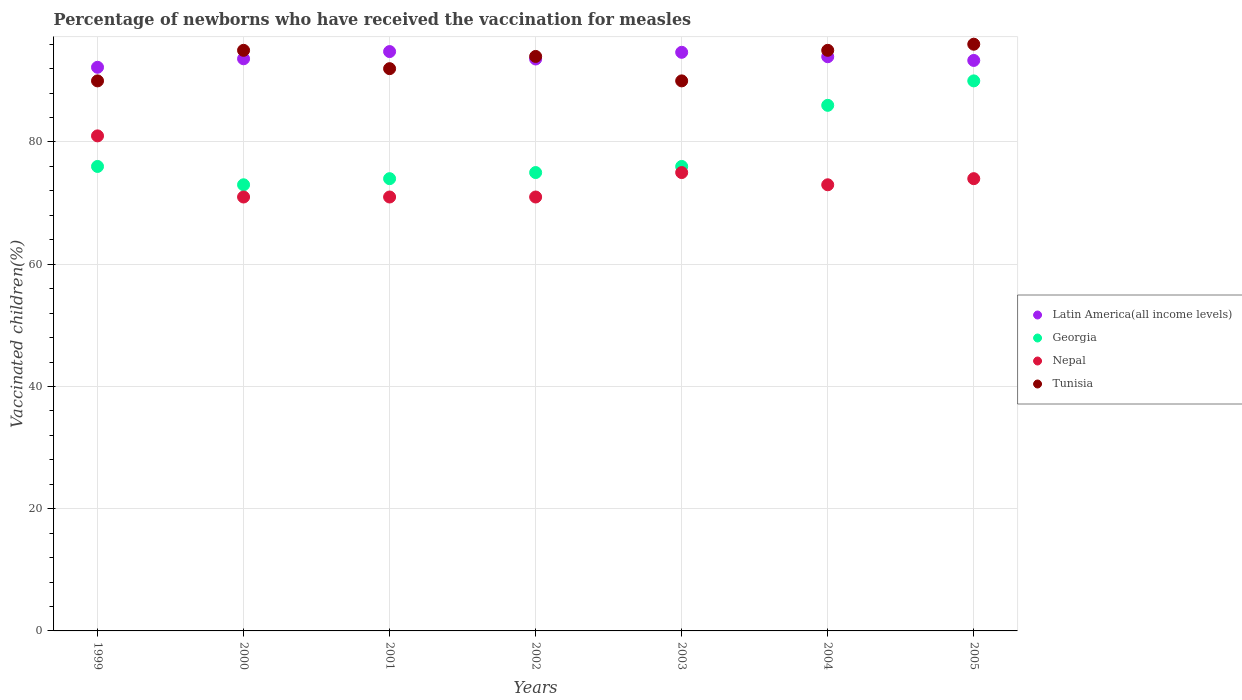Is the number of dotlines equal to the number of legend labels?
Offer a terse response. Yes. Across all years, what is the maximum percentage of vaccinated children in Nepal?
Offer a terse response. 81. In which year was the percentage of vaccinated children in Tunisia minimum?
Provide a short and direct response. 1999. What is the total percentage of vaccinated children in Nepal in the graph?
Provide a short and direct response. 516. What is the difference between the percentage of vaccinated children in Latin America(all income levels) in 1999 and that in 2002?
Keep it short and to the point. -1.36. What is the difference between the percentage of vaccinated children in Tunisia in 1999 and the percentage of vaccinated children in Georgia in 2005?
Provide a succinct answer. 0. What is the average percentage of vaccinated children in Latin America(all income levels) per year?
Your response must be concise. 93.74. In the year 2001, what is the difference between the percentage of vaccinated children in Latin America(all income levels) and percentage of vaccinated children in Nepal?
Provide a short and direct response. 23.8. In how many years, is the percentage of vaccinated children in Georgia greater than 60 %?
Your answer should be compact. 7. What is the ratio of the percentage of vaccinated children in Latin America(all income levels) in 2002 to that in 2003?
Your answer should be compact. 0.99. Is the percentage of vaccinated children in Nepal in 2000 less than that in 2002?
Ensure brevity in your answer.  No. What is the difference between the highest and the second highest percentage of vaccinated children in Nepal?
Keep it short and to the point. 6. What is the difference between the highest and the lowest percentage of vaccinated children in Latin America(all income levels)?
Offer a terse response. 2.57. Is the sum of the percentage of vaccinated children in Georgia in 2000 and 2001 greater than the maximum percentage of vaccinated children in Latin America(all income levels) across all years?
Offer a very short reply. Yes. Is it the case that in every year, the sum of the percentage of vaccinated children in Nepal and percentage of vaccinated children in Georgia  is greater than the sum of percentage of vaccinated children in Latin America(all income levels) and percentage of vaccinated children in Tunisia?
Make the answer very short. No. Is it the case that in every year, the sum of the percentage of vaccinated children in Latin America(all income levels) and percentage of vaccinated children in Georgia  is greater than the percentage of vaccinated children in Tunisia?
Keep it short and to the point. Yes. Is the percentage of vaccinated children in Georgia strictly greater than the percentage of vaccinated children in Tunisia over the years?
Ensure brevity in your answer.  No. What is the difference between two consecutive major ticks on the Y-axis?
Ensure brevity in your answer.  20. Are the values on the major ticks of Y-axis written in scientific E-notation?
Keep it short and to the point. No. How many legend labels are there?
Ensure brevity in your answer.  4. How are the legend labels stacked?
Your response must be concise. Vertical. What is the title of the graph?
Your response must be concise. Percentage of newborns who have received the vaccination for measles. What is the label or title of the Y-axis?
Provide a short and direct response. Vaccinated children(%). What is the Vaccinated children(%) of Latin America(all income levels) in 1999?
Your answer should be very brief. 92.23. What is the Vaccinated children(%) in Georgia in 1999?
Your response must be concise. 76. What is the Vaccinated children(%) in Tunisia in 1999?
Offer a very short reply. 90. What is the Vaccinated children(%) of Latin America(all income levels) in 2000?
Give a very brief answer. 93.62. What is the Vaccinated children(%) in Latin America(all income levels) in 2001?
Provide a short and direct response. 94.8. What is the Vaccinated children(%) in Georgia in 2001?
Offer a very short reply. 74. What is the Vaccinated children(%) in Tunisia in 2001?
Make the answer very short. 92. What is the Vaccinated children(%) in Latin America(all income levels) in 2002?
Give a very brief answer. 93.58. What is the Vaccinated children(%) in Georgia in 2002?
Keep it short and to the point. 75. What is the Vaccinated children(%) in Nepal in 2002?
Your answer should be compact. 71. What is the Vaccinated children(%) of Tunisia in 2002?
Ensure brevity in your answer.  94. What is the Vaccinated children(%) in Latin America(all income levels) in 2003?
Make the answer very short. 94.68. What is the Vaccinated children(%) in Nepal in 2003?
Your answer should be compact. 75. What is the Vaccinated children(%) of Tunisia in 2003?
Provide a short and direct response. 90. What is the Vaccinated children(%) in Latin America(all income levels) in 2004?
Make the answer very short. 93.95. What is the Vaccinated children(%) of Georgia in 2004?
Offer a terse response. 86. What is the Vaccinated children(%) of Nepal in 2004?
Your answer should be very brief. 73. What is the Vaccinated children(%) of Latin America(all income levels) in 2005?
Your answer should be very brief. 93.35. What is the Vaccinated children(%) in Tunisia in 2005?
Make the answer very short. 96. Across all years, what is the maximum Vaccinated children(%) in Latin America(all income levels)?
Your answer should be very brief. 94.8. Across all years, what is the maximum Vaccinated children(%) of Georgia?
Offer a terse response. 90. Across all years, what is the maximum Vaccinated children(%) of Tunisia?
Provide a succinct answer. 96. Across all years, what is the minimum Vaccinated children(%) of Latin America(all income levels)?
Ensure brevity in your answer.  92.23. Across all years, what is the minimum Vaccinated children(%) in Georgia?
Your response must be concise. 73. Across all years, what is the minimum Vaccinated children(%) in Nepal?
Ensure brevity in your answer.  71. What is the total Vaccinated children(%) of Latin America(all income levels) in the graph?
Provide a succinct answer. 656.2. What is the total Vaccinated children(%) in Georgia in the graph?
Ensure brevity in your answer.  550. What is the total Vaccinated children(%) of Nepal in the graph?
Your answer should be compact. 516. What is the total Vaccinated children(%) in Tunisia in the graph?
Offer a very short reply. 652. What is the difference between the Vaccinated children(%) of Latin America(all income levels) in 1999 and that in 2000?
Ensure brevity in your answer.  -1.39. What is the difference between the Vaccinated children(%) in Georgia in 1999 and that in 2000?
Provide a succinct answer. 3. What is the difference between the Vaccinated children(%) of Nepal in 1999 and that in 2000?
Ensure brevity in your answer.  10. What is the difference between the Vaccinated children(%) in Tunisia in 1999 and that in 2000?
Give a very brief answer. -5. What is the difference between the Vaccinated children(%) of Latin America(all income levels) in 1999 and that in 2001?
Your answer should be compact. -2.57. What is the difference between the Vaccinated children(%) in Tunisia in 1999 and that in 2001?
Provide a succinct answer. -2. What is the difference between the Vaccinated children(%) of Latin America(all income levels) in 1999 and that in 2002?
Give a very brief answer. -1.36. What is the difference between the Vaccinated children(%) in Georgia in 1999 and that in 2002?
Provide a succinct answer. 1. What is the difference between the Vaccinated children(%) of Latin America(all income levels) in 1999 and that in 2003?
Ensure brevity in your answer.  -2.45. What is the difference between the Vaccinated children(%) of Georgia in 1999 and that in 2003?
Make the answer very short. 0. What is the difference between the Vaccinated children(%) in Tunisia in 1999 and that in 2003?
Make the answer very short. 0. What is the difference between the Vaccinated children(%) of Latin America(all income levels) in 1999 and that in 2004?
Provide a short and direct response. -1.73. What is the difference between the Vaccinated children(%) of Latin America(all income levels) in 1999 and that in 2005?
Provide a short and direct response. -1.12. What is the difference between the Vaccinated children(%) of Georgia in 1999 and that in 2005?
Ensure brevity in your answer.  -14. What is the difference between the Vaccinated children(%) of Tunisia in 1999 and that in 2005?
Provide a short and direct response. -6. What is the difference between the Vaccinated children(%) in Latin America(all income levels) in 2000 and that in 2001?
Offer a terse response. -1.18. What is the difference between the Vaccinated children(%) of Georgia in 2000 and that in 2001?
Provide a succinct answer. -1. What is the difference between the Vaccinated children(%) of Nepal in 2000 and that in 2001?
Your answer should be very brief. 0. What is the difference between the Vaccinated children(%) in Tunisia in 2000 and that in 2001?
Ensure brevity in your answer.  3. What is the difference between the Vaccinated children(%) of Latin America(all income levels) in 2000 and that in 2002?
Make the answer very short. 0.03. What is the difference between the Vaccinated children(%) in Georgia in 2000 and that in 2002?
Give a very brief answer. -2. What is the difference between the Vaccinated children(%) in Latin America(all income levels) in 2000 and that in 2003?
Your answer should be very brief. -1.06. What is the difference between the Vaccinated children(%) of Nepal in 2000 and that in 2003?
Your response must be concise. -4. What is the difference between the Vaccinated children(%) of Latin America(all income levels) in 2000 and that in 2004?
Make the answer very short. -0.34. What is the difference between the Vaccinated children(%) in Latin America(all income levels) in 2000 and that in 2005?
Provide a short and direct response. 0.27. What is the difference between the Vaccinated children(%) in Tunisia in 2000 and that in 2005?
Make the answer very short. -1. What is the difference between the Vaccinated children(%) in Latin America(all income levels) in 2001 and that in 2002?
Keep it short and to the point. 1.21. What is the difference between the Vaccinated children(%) in Georgia in 2001 and that in 2002?
Offer a terse response. -1. What is the difference between the Vaccinated children(%) in Nepal in 2001 and that in 2002?
Offer a terse response. 0. What is the difference between the Vaccinated children(%) in Tunisia in 2001 and that in 2002?
Provide a succinct answer. -2. What is the difference between the Vaccinated children(%) of Latin America(all income levels) in 2001 and that in 2003?
Your answer should be very brief. 0.12. What is the difference between the Vaccinated children(%) of Tunisia in 2001 and that in 2003?
Offer a very short reply. 2. What is the difference between the Vaccinated children(%) of Latin America(all income levels) in 2001 and that in 2004?
Your answer should be very brief. 0.84. What is the difference between the Vaccinated children(%) of Georgia in 2001 and that in 2004?
Give a very brief answer. -12. What is the difference between the Vaccinated children(%) in Nepal in 2001 and that in 2004?
Keep it short and to the point. -2. What is the difference between the Vaccinated children(%) in Tunisia in 2001 and that in 2004?
Provide a short and direct response. -3. What is the difference between the Vaccinated children(%) of Latin America(all income levels) in 2001 and that in 2005?
Provide a short and direct response. 1.45. What is the difference between the Vaccinated children(%) in Georgia in 2001 and that in 2005?
Your answer should be very brief. -16. What is the difference between the Vaccinated children(%) in Nepal in 2001 and that in 2005?
Ensure brevity in your answer.  -3. What is the difference between the Vaccinated children(%) of Tunisia in 2001 and that in 2005?
Give a very brief answer. -4. What is the difference between the Vaccinated children(%) of Latin America(all income levels) in 2002 and that in 2003?
Provide a succinct answer. -1.09. What is the difference between the Vaccinated children(%) in Latin America(all income levels) in 2002 and that in 2004?
Your answer should be very brief. -0.37. What is the difference between the Vaccinated children(%) of Georgia in 2002 and that in 2004?
Make the answer very short. -11. What is the difference between the Vaccinated children(%) of Nepal in 2002 and that in 2004?
Ensure brevity in your answer.  -2. What is the difference between the Vaccinated children(%) in Latin America(all income levels) in 2002 and that in 2005?
Your answer should be very brief. 0.24. What is the difference between the Vaccinated children(%) of Georgia in 2002 and that in 2005?
Offer a very short reply. -15. What is the difference between the Vaccinated children(%) in Tunisia in 2002 and that in 2005?
Provide a succinct answer. -2. What is the difference between the Vaccinated children(%) in Latin America(all income levels) in 2003 and that in 2004?
Provide a succinct answer. 0.72. What is the difference between the Vaccinated children(%) in Latin America(all income levels) in 2003 and that in 2005?
Your answer should be compact. 1.33. What is the difference between the Vaccinated children(%) in Georgia in 2003 and that in 2005?
Ensure brevity in your answer.  -14. What is the difference between the Vaccinated children(%) of Nepal in 2003 and that in 2005?
Offer a very short reply. 1. What is the difference between the Vaccinated children(%) of Tunisia in 2003 and that in 2005?
Offer a terse response. -6. What is the difference between the Vaccinated children(%) of Latin America(all income levels) in 2004 and that in 2005?
Your response must be concise. 0.61. What is the difference between the Vaccinated children(%) in Nepal in 2004 and that in 2005?
Provide a succinct answer. -1. What is the difference between the Vaccinated children(%) in Latin America(all income levels) in 1999 and the Vaccinated children(%) in Georgia in 2000?
Provide a short and direct response. 19.23. What is the difference between the Vaccinated children(%) in Latin America(all income levels) in 1999 and the Vaccinated children(%) in Nepal in 2000?
Your answer should be very brief. 21.23. What is the difference between the Vaccinated children(%) in Latin America(all income levels) in 1999 and the Vaccinated children(%) in Tunisia in 2000?
Offer a very short reply. -2.77. What is the difference between the Vaccinated children(%) in Georgia in 1999 and the Vaccinated children(%) in Nepal in 2000?
Provide a short and direct response. 5. What is the difference between the Vaccinated children(%) in Georgia in 1999 and the Vaccinated children(%) in Tunisia in 2000?
Give a very brief answer. -19. What is the difference between the Vaccinated children(%) of Latin America(all income levels) in 1999 and the Vaccinated children(%) of Georgia in 2001?
Give a very brief answer. 18.23. What is the difference between the Vaccinated children(%) in Latin America(all income levels) in 1999 and the Vaccinated children(%) in Nepal in 2001?
Ensure brevity in your answer.  21.23. What is the difference between the Vaccinated children(%) of Latin America(all income levels) in 1999 and the Vaccinated children(%) of Tunisia in 2001?
Your answer should be very brief. 0.23. What is the difference between the Vaccinated children(%) of Georgia in 1999 and the Vaccinated children(%) of Tunisia in 2001?
Keep it short and to the point. -16. What is the difference between the Vaccinated children(%) of Latin America(all income levels) in 1999 and the Vaccinated children(%) of Georgia in 2002?
Your answer should be compact. 17.23. What is the difference between the Vaccinated children(%) in Latin America(all income levels) in 1999 and the Vaccinated children(%) in Nepal in 2002?
Keep it short and to the point. 21.23. What is the difference between the Vaccinated children(%) of Latin America(all income levels) in 1999 and the Vaccinated children(%) of Tunisia in 2002?
Provide a short and direct response. -1.77. What is the difference between the Vaccinated children(%) of Georgia in 1999 and the Vaccinated children(%) of Nepal in 2002?
Ensure brevity in your answer.  5. What is the difference between the Vaccinated children(%) in Georgia in 1999 and the Vaccinated children(%) in Tunisia in 2002?
Your answer should be very brief. -18. What is the difference between the Vaccinated children(%) of Latin America(all income levels) in 1999 and the Vaccinated children(%) of Georgia in 2003?
Your response must be concise. 16.23. What is the difference between the Vaccinated children(%) of Latin America(all income levels) in 1999 and the Vaccinated children(%) of Nepal in 2003?
Offer a terse response. 17.23. What is the difference between the Vaccinated children(%) of Latin America(all income levels) in 1999 and the Vaccinated children(%) of Tunisia in 2003?
Offer a very short reply. 2.23. What is the difference between the Vaccinated children(%) of Latin America(all income levels) in 1999 and the Vaccinated children(%) of Georgia in 2004?
Your answer should be very brief. 6.23. What is the difference between the Vaccinated children(%) of Latin America(all income levels) in 1999 and the Vaccinated children(%) of Nepal in 2004?
Give a very brief answer. 19.23. What is the difference between the Vaccinated children(%) of Latin America(all income levels) in 1999 and the Vaccinated children(%) of Tunisia in 2004?
Your response must be concise. -2.77. What is the difference between the Vaccinated children(%) of Georgia in 1999 and the Vaccinated children(%) of Tunisia in 2004?
Provide a succinct answer. -19. What is the difference between the Vaccinated children(%) in Nepal in 1999 and the Vaccinated children(%) in Tunisia in 2004?
Ensure brevity in your answer.  -14. What is the difference between the Vaccinated children(%) of Latin America(all income levels) in 1999 and the Vaccinated children(%) of Georgia in 2005?
Your answer should be very brief. 2.23. What is the difference between the Vaccinated children(%) of Latin America(all income levels) in 1999 and the Vaccinated children(%) of Nepal in 2005?
Keep it short and to the point. 18.23. What is the difference between the Vaccinated children(%) in Latin America(all income levels) in 1999 and the Vaccinated children(%) in Tunisia in 2005?
Your answer should be compact. -3.77. What is the difference between the Vaccinated children(%) of Latin America(all income levels) in 2000 and the Vaccinated children(%) of Georgia in 2001?
Ensure brevity in your answer.  19.62. What is the difference between the Vaccinated children(%) in Latin America(all income levels) in 2000 and the Vaccinated children(%) in Nepal in 2001?
Ensure brevity in your answer.  22.62. What is the difference between the Vaccinated children(%) of Latin America(all income levels) in 2000 and the Vaccinated children(%) of Tunisia in 2001?
Offer a terse response. 1.62. What is the difference between the Vaccinated children(%) in Georgia in 2000 and the Vaccinated children(%) in Nepal in 2001?
Give a very brief answer. 2. What is the difference between the Vaccinated children(%) of Georgia in 2000 and the Vaccinated children(%) of Tunisia in 2001?
Provide a succinct answer. -19. What is the difference between the Vaccinated children(%) of Latin America(all income levels) in 2000 and the Vaccinated children(%) of Georgia in 2002?
Offer a terse response. 18.62. What is the difference between the Vaccinated children(%) of Latin America(all income levels) in 2000 and the Vaccinated children(%) of Nepal in 2002?
Offer a very short reply. 22.62. What is the difference between the Vaccinated children(%) in Latin America(all income levels) in 2000 and the Vaccinated children(%) in Tunisia in 2002?
Offer a very short reply. -0.38. What is the difference between the Vaccinated children(%) in Georgia in 2000 and the Vaccinated children(%) in Tunisia in 2002?
Provide a succinct answer. -21. What is the difference between the Vaccinated children(%) in Nepal in 2000 and the Vaccinated children(%) in Tunisia in 2002?
Offer a very short reply. -23. What is the difference between the Vaccinated children(%) in Latin America(all income levels) in 2000 and the Vaccinated children(%) in Georgia in 2003?
Your response must be concise. 17.62. What is the difference between the Vaccinated children(%) in Latin America(all income levels) in 2000 and the Vaccinated children(%) in Nepal in 2003?
Keep it short and to the point. 18.62. What is the difference between the Vaccinated children(%) of Latin America(all income levels) in 2000 and the Vaccinated children(%) of Tunisia in 2003?
Offer a terse response. 3.62. What is the difference between the Vaccinated children(%) of Georgia in 2000 and the Vaccinated children(%) of Nepal in 2003?
Provide a short and direct response. -2. What is the difference between the Vaccinated children(%) in Nepal in 2000 and the Vaccinated children(%) in Tunisia in 2003?
Your response must be concise. -19. What is the difference between the Vaccinated children(%) in Latin America(all income levels) in 2000 and the Vaccinated children(%) in Georgia in 2004?
Provide a succinct answer. 7.62. What is the difference between the Vaccinated children(%) of Latin America(all income levels) in 2000 and the Vaccinated children(%) of Nepal in 2004?
Provide a short and direct response. 20.62. What is the difference between the Vaccinated children(%) in Latin America(all income levels) in 2000 and the Vaccinated children(%) in Tunisia in 2004?
Offer a very short reply. -1.38. What is the difference between the Vaccinated children(%) of Georgia in 2000 and the Vaccinated children(%) of Nepal in 2004?
Provide a succinct answer. 0. What is the difference between the Vaccinated children(%) in Nepal in 2000 and the Vaccinated children(%) in Tunisia in 2004?
Make the answer very short. -24. What is the difference between the Vaccinated children(%) of Latin America(all income levels) in 2000 and the Vaccinated children(%) of Georgia in 2005?
Offer a very short reply. 3.62. What is the difference between the Vaccinated children(%) in Latin America(all income levels) in 2000 and the Vaccinated children(%) in Nepal in 2005?
Provide a short and direct response. 19.62. What is the difference between the Vaccinated children(%) in Latin America(all income levels) in 2000 and the Vaccinated children(%) in Tunisia in 2005?
Offer a terse response. -2.38. What is the difference between the Vaccinated children(%) in Nepal in 2000 and the Vaccinated children(%) in Tunisia in 2005?
Your answer should be compact. -25. What is the difference between the Vaccinated children(%) in Latin America(all income levels) in 2001 and the Vaccinated children(%) in Georgia in 2002?
Offer a terse response. 19.8. What is the difference between the Vaccinated children(%) in Latin America(all income levels) in 2001 and the Vaccinated children(%) in Nepal in 2002?
Your answer should be very brief. 23.8. What is the difference between the Vaccinated children(%) of Latin America(all income levels) in 2001 and the Vaccinated children(%) of Tunisia in 2002?
Offer a terse response. 0.8. What is the difference between the Vaccinated children(%) in Georgia in 2001 and the Vaccinated children(%) in Nepal in 2002?
Give a very brief answer. 3. What is the difference between the Vaccinated children(%) of Georgia in 2001 and the Vaccinated children(%) of Tunisia in 2002?
Provide a short and direct response. -20. What is the difference between the Vaccinated children(%) of Latin America(all income levels) in 2001 and the Vaccinated children(%) of Georgia in 2003?
Offer a terse response. 18.8. What is the difference between the Vaccinated children(%) of Latin America(all income levels) in 2001 and the Vaccinated children(%) of Nepal in 2003?
Your response must be concise. 19.8. What is the difference between the Vaccinated children(%) in Latin America(all income levels) in 2001 and the Vaccinated children(%) in Tunisia in 2003?
Offer a terse response. 4.8. What is the difference between the Vaccinated children(%) of Georgia in 2001 and the Vaccinated children(%) of Tunisia in 2003?
Your answer should be compact. -16. What is the difference between the Vaccinated children(%) of Latin America(all income levels) in 2001 and the Vaccinated children(%) of Georgia in 2004?
Offer a terse response. 8.8. What is the difference between the Vaccinated children(%) in Latin America(all income levels) in 2001 and the Vaccinated children(%) in Nepal in 2004?
Ensure brevity in your answer.  21.8. What is the difference between the Vaccinated children(%) of Latin America(all income levels) in 2001 and the Vaccinated children(%) of Tunisia in 2004?
Your response must be concise. -0.2. What is the difference between the Vaccinated children(%) of Nepal in 2001 and the Vaccinated children(%) of Tunisia in 2004?
Give a very brief answer. -24. What is the difference between the Vaccinated children(%) of Latin America(all income levels) in 2001 and the Vaccinated children(%) of Georgia in 2005?
Ensure brevity in your answer.  4.8. What is the difference between the Vaccinated children(%) of Latin America(all income levels) in 2001 and the Vaccinated children(%) of Nepal in 2005?
Offer a very short reply. 20.8. What is the difference between the Vaccinated children(%) of Latin America(all income levels) in 2001 and the Vaccinated children(%) of Tunisia in 2005?
Your answer should be very brief. -1.2. What is the difference between the Vaccinated children(%) of Nepal in 2001 and the Vaccinated children(%) of Tunisia in 2005?
Make the answer very short. -25. What is the difference between the Vaccinated children(%) of Latin America(all income levels) in 2002 and the Vaccinated children(%) of Georgia in 2003?
Your answer should be compact. 17.58. What is the difference between the Vaccinated children(%) in Latin America(all income levels) in 2002 and the Vaccinated children(%) in Nepal in 2003?
Make the answer very short. 18.58. What is the difference between the Vaccinated children(%) in Latin America(all income levels) in 2002 and the Vaccinated children(%) in Tunisia in 2003?
Provide a short and direct response. 3.58. What is the difference between the Vaccinated children(%) of Georgia in 2002 and the Vaccinated children(%) of Nepal in 2003?
Provide a short and direct response. 0. What is the difference between the Vaccinated children(%) in Nepal in 2002 and the Vaccinated children(%) in Tunisia in 2003?
Your answer should be very brief. -19. What is the difference between the Vaccinated children(%) of Latin America(all income levels) in 2002 and the Vaccinated children(%) of Georgia in 2004?
Your answer should be compact. 7.58. What is the difference between the Vaccinated children(%) of Latin America(all income levels) in 2002 and the Vaccinated children(%) of Nepal in 2004?
Make the answer very short. 20.58. What is the difference between the Vaccinated children(%) in Latin America(all income levels) in 2002 and the Vaccinated children(%) in Tunisia in 2004?
Your answer should be very brief. -1.42. What is the difference between the Vaccinated children(%) in Georgia in 2002 and the Vaccinated children(%) in Nepal in 2004?
Make the answer very short. 2. What is the difference between the Vaccinated children(%) in Latin America(all income levels) in 2002 and the Vaccinated children(%) in Georgia in 2005?
Provide a succinct answer. 3.58. What is the difference between the Vaccinated children(%) in Latin America(all income levels) in 2002 and the Vaccinated children(%) in Nepal in 2005?
Offer a terse response. 19.58. What is the difference between the Vaccinated children(%) in Latin America(all income levels) in 2002 and the Vaccinated children(%) in Tunisia in 2005?
Make the answer very short. -2.42. What is the difference between the Vaccinated children(%) in Georgia in 2002 and the Vaccinated children(%) in Tunisia in 2005?
Your answer should be compact. -21. What is the difference between the Vaccinated children(%) of Latin America(all income levels) in 2003 and the Vaccinated children(%) of Georgia in 2004?
Provide a succinct answer. 8.68. What is the difference between the Vaccinated children(%) in Latin America(all income levels) in 2003 and the Vaccinated children(%) in Nepal in 2004?
Offer a terse response. 21.68. What is the difference between the Vaccinated children(%) in Latin America(all income levels) in 2003 and the Vaccinated children(%) in Tunisia in 2004?
Your answer should be very brief. -0.32. What is the difference between the Vaccinated children(%) of Nepal in 2003 and the Vaccinated children(%) of Tunisia in 2004?
Your response must be concise. -20. What is the difference between the Vaccinated children(%) in Latin America(all income levels) in 2003 and the Vaccinated children(%) in Georgia in 2005?
Provide a succinct answer. 4.68. What is the difference between the Vaccinated children(%) in Latin America(all income levels) in 2003 and the Vaccinated children(%) in Nepal in 2005?
Provide a succinct answer. 20.68. What is the difference between the Vaccinated children(%) of Latin America(all income levels) in 2003 and the Vaccinated children(%) of Tunisia in 2005?
Provide a succinct answer. -1.32. What is the difference between the Vaccinated children(%) in Latin America(all income levels) in 2004 and the Vaccinated children(%) in Georgia in 2005?
Make the answer very short. 3.95. What is the difference between the Vaccinated children(%) of Latin America(all income levels) in 2004 and the Vaccinated children(%) of Nepal in 2005?
Provide a succinct answer. 19.95. What is the difference between the Vaccinated children(%) in Latin America(all income levels) in 2004 and the Vaccinated children(%) in Tunisia in 2005?
Provide a short and direct response. -2.05. What is the difference between the Vaccinated children(%) in Georgia in 2004 and the Vaccinated children(%) in Nepal in 2005?
Your response must be concise. 12. What is the average Vaccinated children(%) of Latin America(all income levels) per year?
Offer a very short reply. 93.74. What is the average Vaccinated children(%) in Georgia per year?
Your response must be concise. 78.57. What is the average Vaccinated children(%) in Nepal per year?
Offer a very short reply. 73.71. What is the average Vaccinated children(%) in Tunisia per year?
Offer a terse response. 93.14. In the year 1999, what is the difference between the Vaccinated children(%) in Latin America(all income levels) and Vaccinated children(%) in Georgia?
Your answer should be compact. 16.23. In the year 1999, what is the difference between the Vaccinated children(%) of Latin America(all income levels) and Vaccinated children(%) of Nepal?
Provide a succinct answer. 11.23. In the year 1999, what is the difference between the Vaccinated children(%) of Latin America(all income levels) and Vaccinated children(%) of Tunisia?
Keep it short and to the point. 2.23. In the year 1999, what is the difference between the Vaccinated children(%) of Georgia and Vaccinated children(%) of Nepal?
Your response must be concise. -5. In the year 1999, what is the difference between the Vaccinated children(%) of Georgia and Vaccinated children(%) of Tunisia?
Give a very brief answer. -14. In the year 1999, what is the difference between the Vaccinated children(%) in Nepal and Vaccinated children(%) in Tunisia?
Your response must be concise. -9. In the year 2000, what is the difference between the Vaccinated children(%) of Latin America(all income levels) and Vaccinated children(%) of Georgia?
Give a very brief answer. 20.62. In the year 2000, what is the difference between the Vaccinated children(%) of Latin America(all income levels) and Vaccinated children(%) of Nepal?
Offer a terse response. 22.62. In the year 2000, what is the difference between the Vaccinated children(%) of Latin America(all income levels) and Vaccinated children(%) of Tunisia?
Your answer should be compact. -1.38. In the year 2001, what is the difference between the Vaccinated children(%) of Latin America(all income levels) and Vaccinated children(%) of Georgia?
Ensure brevity in your answer.  20.8. In the year 2001, what is the difference between the Vaccinated children(%) in Latin America(all income levels) and Vaccinated children(%) in Nepal?
Provide a short and direct response. 23.8. In the year 2001, what is the difference between the Vaccinated children(%) of Latin America(all income levels) and Vaccinated children(%) of Tunisia?
Your answer should be compact. 2.8. In the year 2001, what is the difference between the Vaccinated children(%) in Georgia and Vaccinated children(%) in Nepal?
Make the answer very short. 3. In the year 2001, what is the difference between the Vaccinated children(%) in Nepal and Vaccinated children(%) in Tunisia?
Ensure brevity in your answer.  -21. In the year 2002, what is the difference between the Vaccinated children(%) of Latin America(all income levels) and Vaccinated children(%) of Georgia?
Give a very brief answer. 18.58. In the year 2002, what is the difference between the Vaccinated children(%) of Latin America(all income levels) and Vaccinated children(%) of Nepal?
Make the answer very short. 22.58. In the year 2002, what is the difference between the Vaccinated children(%) of Latin America(all income levels) and Vaccinated children(%) of Tunisia?
Ensure brevity in your answer.  -0.42. In the year 2002, what is the difference between the Vaccinated children(%) of Georgia and Vaccinated children(%) of Nepal?
Ensure brevity in your answer.  4. In the year 2002, what is the difference between the Vaccinated children(%) of Georgia and Vaccinated children(%) of Tunisia?
Provide a short and direct response. -19. In the year 2002, what is the difference between the Vaccinated children(%) in Nepal and Vaccinated children(%) in Tunisia?
Provide a short and direct response. -23. In the year 2003, what is the difference between the Vaccinated children(%) in Latin America(all income levels) and Vaccinated children(%) in Georgia?
Make the answer very short. 18.68. In the year 2003, what is the difference between the Vaccinated children(%) of Latin America(all income levels) and Vaccinated children(%) of Nepal?
Offer a terse response. 19.68. In the year 2003, what is the difference between the Vaccinated children(%) of Latin America(all income levels) and Vaccinated children(%) of Tunisia?
Your response must be concise. 4.68. In the year 2003, what is the difference between the Vaccinated children(%) of Nepal and Vaccinated children(%) of Tunisia?
Provide a short and direct response. -15. In the year 2004, what is the difference between the Vaccinated children(%) in Latin America(all income levels) and Vaccinated children(%) in Georgia?
Keep it short and to the point. 7.95. In the year 2004, what is the difference between the Vaccinated children(%) in Latin America(all income levels) and Vaccinated children(%) in Nepal?
Offer a very short reply. 20.95. In the year 2004, what is the difference between the Vaccinated children(%) of Latin America(all income levels) and Vaccinated children(%) of Tunisia?
Make the answer very short. -1.05. In the year 2004, what is the difference between the Vaccinated children(%) of Georgia and Vaccinated children(%) of Tunisia?
Provide a succinct answer. -9. In the year 2005, what is the difference between the Vaccinated children(%) in Latin America(all income levels) and Vaccinated children(%) in Georgia?
Your answer should be compact. 3.35. In the year 2005, what is the difference between the Vaccinated children(%) of Latin America(all income levels) and Vaccinated children(%) of Nepal?
Offer a very short reply. 19.35. In the year 2005, what is the difference between the Vaccinated children(%) in Latin America(all income levels) and Vaccinated children(%) in Tunisia?
Your answer should be very brief. -2.65. In the year 2005, what is the difference between the Vaccinated children(%) of Georgia and Vaccinated children(%) of Nepal?
Give a very brief answer. 16. In the year 2005, what is the difference between the Vaccinated children(%) of Nepal and Vaccinated children(%) of Tunisia?
Make the answer very short. -22. What is the ratio of the Vaccinated children(%) of Latin America(all income levels) in 1999 to that in 2000?
Your answer should be very brief. 0.99. What is the ratio of the Vaccinated children(%) in Georgia in 1999 to that in 2000?
Ensure brevity in your answer.  1.04. What is the ratio of the Vaccinated children(%) of Nepal in 1999 to that in 2000?
Provide a succinct answer. 1.14. What is the ratio of the Vaccinated children(%) in Tunisia in 1999 to that in 2000?
Offer a very short reply. 0.95. What is the ratio of the Vaccinated children(%) in Latin America(all income levels) in 1999 to that in 2001?
Offer a terse response. 0.97. What is the ratio of the Vaccinated children(%) of Nepal in 1999 to that in 2001?
Ensure brevity in your answer.  1.14. What is the ratio of the Vaccinated children(%) in Tunisia in 1999 to that in 2001?
Provide a short and direct response. 0.98. What is the ratio of the Vaccinated children(%) in Latin America(all income levels) in 1999 to that in 2002?
Provide a short and direct response. 0.99. What is the ratio of the Vaccinated children(%) in Georgia in 1999 to that in 2002?
Keep it short and to the point. 1.01. What is the ratio of the Vaccinated children(%) of Nepal in 1999 to that in 2002?
Provide a succinct answer. 1.14. What is the ratio of the Vaccinated children(%) of Tunisia in 1999 to that in 2002?
Make the answer very short. 0.96. What is the ratio of the Vaccinated children(%) of Latin America(all income levels) in 1999 to that in 2003?
Your response must be concise. 0.97. What is the ratio of the Vaccinated children(%) of Nepal in 1999 to that in 2003?
Provide a short and direct response. 1.08. What is the ratio of the Vaccinated children(%) of Latin America(all income levels) in 1999 to that in 2004?
Offer a very short reply. 0.98. What is the ratio of the Vaccinated children(%) of Georgia in 1999 to that in 2004?
Your answer should be very brief. 0.88. What is the ratio of the Vaccinated children(%) of Nepal in 1999 to that in 2004?
Provide a succinct answer. 1.11. What is the ratio of the Vaccinated children(%) of Georgia in 1999 to that in 2005?
Offer a very short reply. 0.84. What is the ratio of the Vaccinated children(%) in Nepal in 1999 to that in 2005?
Ensure brevity in your answer.  1.09. What is the ratio of the Vaccinated children(%) in Tunisia in 1999 to that in 2005?
Your answer should be compact. 0.94. What is the ratio of the Vaccinated children(%) in Latin America(all income levels) in 2000 to that in 2001?
Ensure brevity in your answer.  0.99. What is the ratio of the Vaccinated children(%) of Georgia in 2000 to that in 2001?
Your answer should be very brief. 0.99. What is the ratio of the Vaccinated children(%) of Tunisia in 2000 to that in 2001?
Keep it short and to the point. 1.03. What is the ratio of the Vaccinated children(%) in Georgia in 2000 to that in 2002?
Your response must be concise. 0.97. What is the ratio of the Vaccinated children(%) of Tunisia in 2000 to that in 2002?
Offer a terse response. 1.01. What is the ratio of the Vaccinated children(%) of Latin America(all income levels) in 2000 to that in 2003?
Ensure brevity in your answer.  0.99. What is the ratio of the Vaccinated children(%) in Georgia in 2000 to that in 2003?
Offer a very short reply. 0.96. What is the ratio of the Vaccinated children(%) of Nepal in 2000 to that in 2003?
Provide a succinct answer. 0.95. What is the ratio of the Vaccinated children(%) of Tunisia in 2000 to that in 2003?
Provide a succinct answer. 1.06. What is the ratio of the Vaccinated children(%) of Georgia in 2000 to that in 2004?
Make the answer very short. 0.85. What is the ratio of the Vaccinated children(%) in Nepal in 2000 to that in 2004?
Provide a short and direct response. 0.97. What is the ratio of the Vaccinated children(%) in Tunisia in 2000 to that in 2004?
Keep it short and to the point. 1. What is the ratio of the Vaccinated children(%) of Latin America(all income levels) in 2000 to that in 2005?
Offer a very short reply. 1. What is the ratio of the Vaccinated children(%) in Georgia in 2000 to that in 2005?
Keep it short and to the point. 0.81. What is the ratio of the Vaccinated children(%) in Nepal in 2000 to that in 2005?
Ensure brevity in your answer.  0.96. What is the ratio of the Vaccinated children(%) in Latin America(all income levels) in 2001 to that in 2002?
Provide a succinct answer. 1.01. What is the ratio of the Vaccinated children(%) of Georgia in 2001 to that in 2002?
Give a very brief answer. 0.99. What is the ratio of the Vaccinated children(%) of Nepal in 2001 to that in 2002?
Your answer should be compact. 1. What is the ratio of the Vaccinated children(%) of Tunisia in 2001 to that in 2002?
Your answer should be very brief. 0.98. What is the ratio of the Vaccinated children(%) in Georgia in 2001 to that in 2003?
Your answer should be very brief. 0.97. What is the ratio of the Vaccinated children(%) of Nepal in 2001 to that in 2003?
Offer a very short reply. 0.95. What is the ratio of the Vaccinated children(%) in Tunisia in 2001 to that in 2003?
Make the answer very short. 1.02. What is the ratio of the Vaccinated children(%) in Latin America(all income levels) in 2001 to that in 2004?
Your response must be concise. 1.01. What is the ratio of the Vaccinated children(%) of Georgia in 2001 to that in 2004?
Your response must be concise. 0.86. What is the ratio of the Vaccinated children(%) in Nepal in 2001 to that in 2004?
Ensure brevity in your answer.  0.97. What is the ratio of the Vaccinated children(%) in Tunisia in 2001 to that in 2004?
Provide a short and direct response. 0.97. What is the ratio of the Vaccinated children(%) of Latin America(all income levels) in 2001 to that in 2005?
Offer a very short reply. 1.02. What is the ratio of the Vaccinated children(%) in Georgia in 2001 to that in 2005?
Your answer should be very brief. 0.82. What is the ratio of the Vaccinated children(%) in Nepal in 2001 to that in 2005?
Offer a terse response. 0.96. What is the ratio of the Vaccinated children(%) of Tunisia in 2001 to that in 2005?
Provide a succinct answer. 0.96. What is the ratio of the Vaccinated children(%) of Nepal in 2002 to that in 2003?
Your response must be concise. 0.95. What is the ratio of the Vaccinated children(%) in Tunisia in 2002 to that in 2003?
Provide a succinct answer. 1.04. What is the ratio of the Vaccinated children(%) in Georgia in 2002 to that in 2004?
Give a very brief answer. 0.87. What is the ratio of the Vaccinated children(%) of Nepal in 2002 to that in 2004?
Offer a terse response. 0.97. What is the ratio of the Vaccinated children(%) in Tunisia in 2002 to that in 2004?
Give a very brief answer. 0.99. What is the ratio of the Vaccinated children(%) in Georgia in 2002 to that in 2005?
Keep it short and to the point. 0.83. What is the ratio of the Vaccinated children(%) in Nepal in 2002 to that in 2005?
Provide a short and direct response. 0.96. What is the ratio of the Vaccinated children(%) in Tunisia in 2002 to that in 2005?
Provide a short and direct response. 0.98. What is the ratio of the Vaccinated children(%) of Latin America(all income levels) in 2003 to that in 2004?
Your answer should be very brief. 1.01. What is the ratio of the Vaccinated children(%) in Georgia in 2003 to that in 2004?
Make the answer very short. 0.88. What is the ratio of the Vaccinated children(%) in Nepal in 2003 to that in 2004?
Provide a succinct answer. 1.03. What is the ratio of the Vaccinated children(%) in Tunisia in 2003 to that in 2004?
Your answer should be compact. 0.95. What is the ratio of the Vaccinated children(%) of Latin America(all income levels) in 2003 to that in 2005?
Give a very brief answer. 1.01. What is the ratio of the Vaccinated children(%) of Georgia in 2003 to that in 2005?
Your answer should be very brief. 0.84. What is the ratio of the Vaccinated children(%) in Nepal in 2003 to that in 2005?
Keep it short and to the point. 1.01. What is the ratio of the Vaccinated children(%) in Tunisia in 2003 to that in 2005?
Provide a succinct answer. 0.94. What is the ratio of the Vaccinated children(%) in Latin America(all income levels) in 2004 to that in 2005?
Make the answer very short. 1.01. What is the ratio of the Vaccinated children(%) in Georgia in 2004 to that in 2005?
Provide a succinct answer. 0.96. What is the ratio of the Vaccinated children(%) in Nepal in 2004 to that in 2005?
Make the answer very short. 0.99. What is the difference between the highest and the second highest Vaccinated children(%) in Latin America(all income levels)?
Provide a short and direct response. 0.12. What is the difference between the highest and the second highest Vaccinated children(%) in Georgia?
Make the answer very short. 4. What is the difference between the highest and the second highest Vaccinated children(%) of Nepal?
Offer a very short reply. 6. What is the difference between the highest and the second highest Vaccinated children(%) of Tunisia?
Keep it short and to the point. 1. What is the difference between the highest and the lowest Vaccinated children(%) of Latin America(all income levels)?
Provide a short and direct response. 2.57. What is the difference between the highest and the lowest Vaccinated children(%) in Nepal?
Offer a very short reply. 10. What is the difference between the highest and the lowest Vaccinated children(%) in Tunisia?
Keep it short and to the point. 6. 